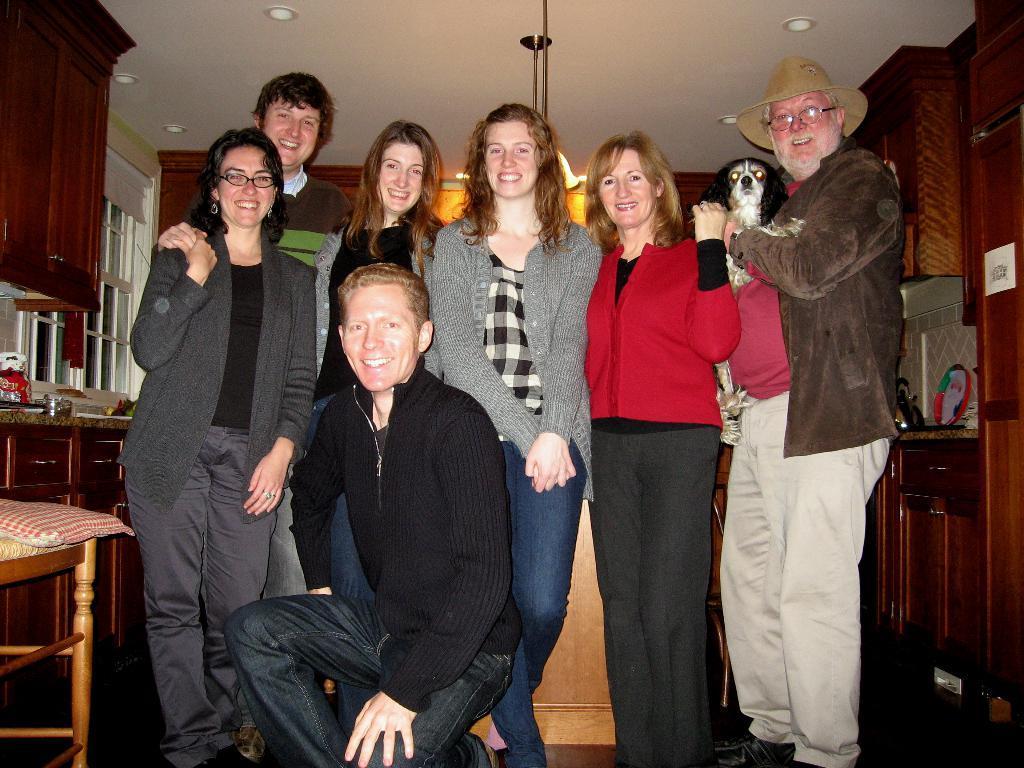Can you describe this image briefly? In the image I can see some people wearing jackets and around there are some cupboards, chair and some other things around. 